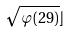Convert formula to latex. <formula><loc_0><loc_0><loc_500><loc_500>\sqrt { \varphi ( 2 9 ) } \rfloor</formula> 